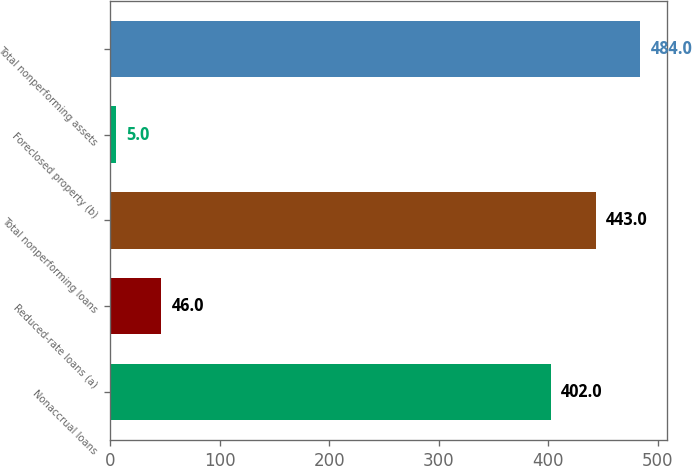Convert chart. <chart><loc_0><loc_0><loc_500><loc_500><bar_chart><fcel>Nonaccrual loans<fcel>Reduced-rate loans (a)<fcel>Total nonperforming loans<fcel>Foreclosed property (b)<fcel>Total nonperforming assets<nl><fcel>402<fcel>46<fcel>443<fcel>5<fcel>484<nl></chart> 